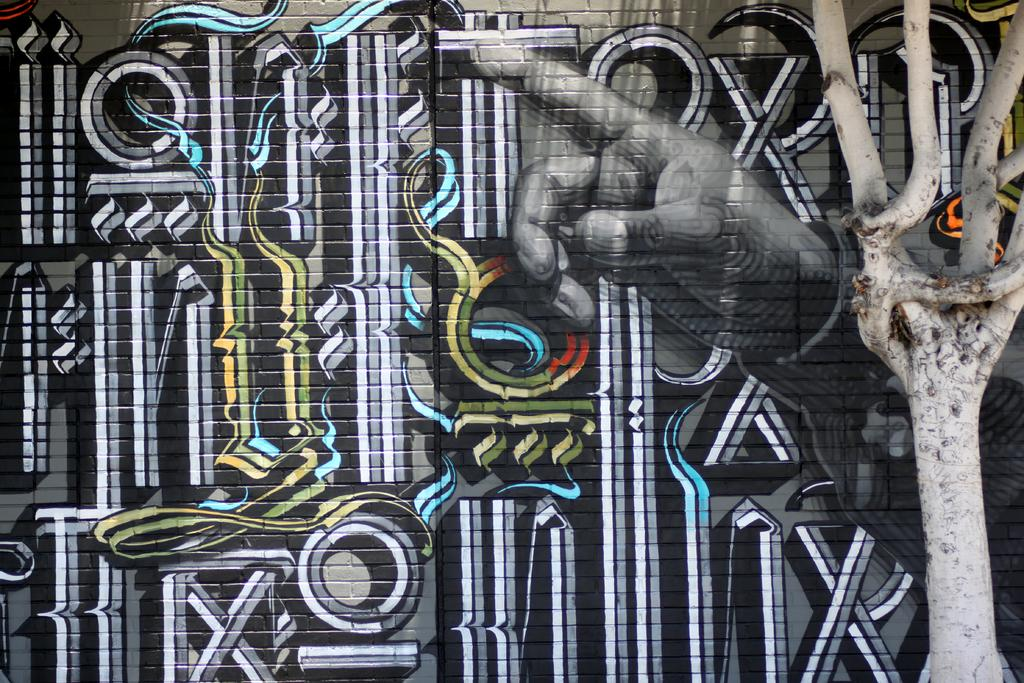What is depicted on the wall in the image? There is a wall painting in the image. What can be observed about the colors used in the wall painting? The wall painting has different colors. What type of natural element is visible in the image? There is a tree visible in the image. How many kittens are playing with the oven in the image? There are no kittens or ovens present in the image. 